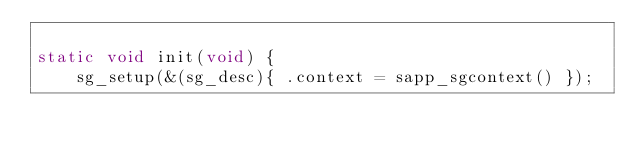Convert code to text. <code><loc_0><loc_0><loc_500><loc_500><_C_>
static void init(void) {
    sg_setup(&(sg_desc){ .context = sapp_sgcontext() });</code> 